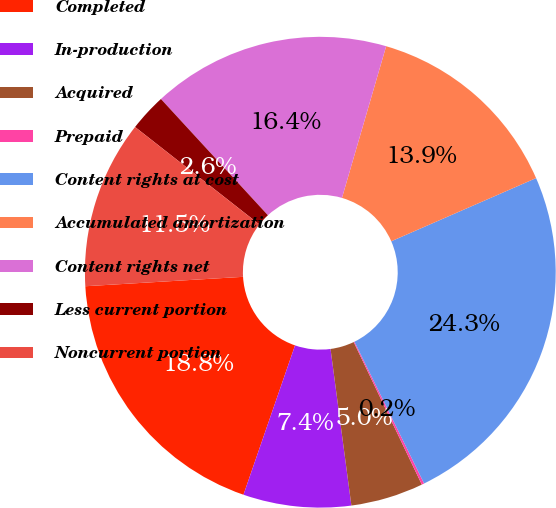Convert chart to OTSL. <chart><loc_0><loc_0><loc_500><loc_500><pie_chart><fcel>Completed<fcel>In-production<fcel>Acquired<fcel>Prepaid<fcel>Content rights at cost<fcel>Accumulated amortization<fcel>Content rights net<fcel>Less current portion<fcel>Noncurrent portion<nl><fcel>18.76%<fcel>7.4%<fcel>4.99%<fcel>0.17%<fcel>24.28%<fcel>13.94%<fcel>16.35%<fcel>2.58%<fcel>11.53%<nl></chart> 